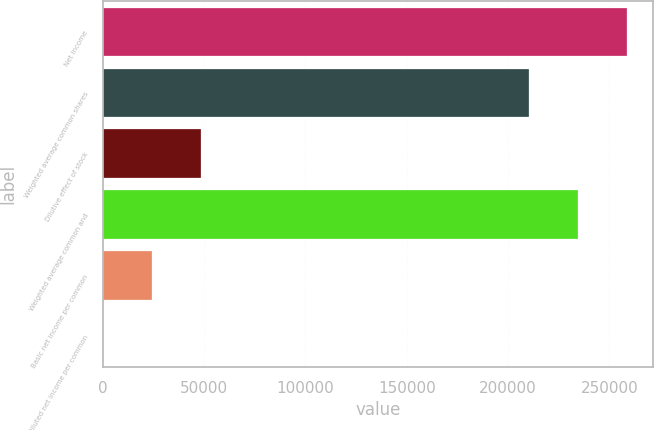Convert chart. <chart><loc_0><loc_0><loc_500><loc_500><bar_chart><fcel>Net income<fcel>Weighted average common shares<fcel>Dilutive effect of stock<fcel>Weighted average common and<fcel>Basic net income per common<fcel>Diluted net income per common<nl><fcel>258578<fcel>210104<fcel>48474.7<fcel>234341<fcel>24237.9<fcel>1.13<nl></chart> 